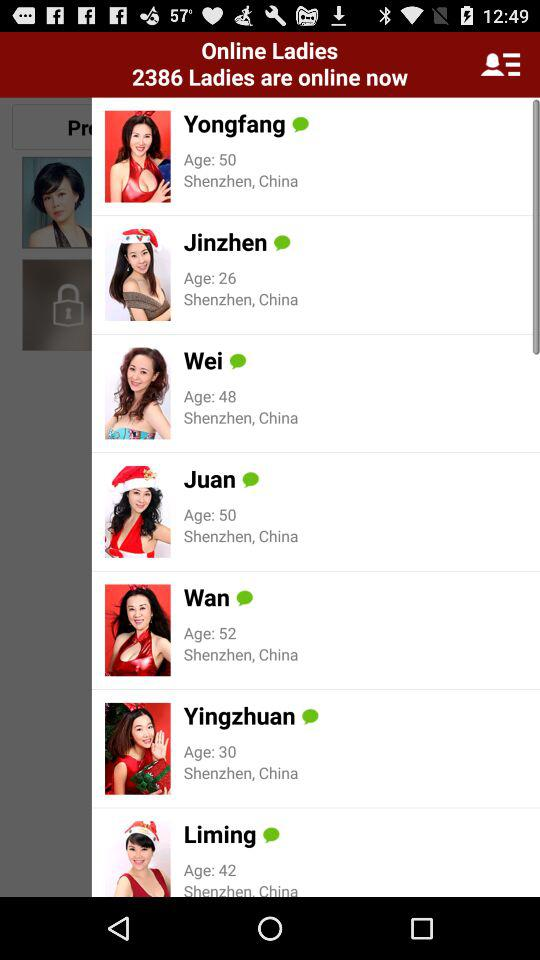How far away is Juan?
When the provided information is insufficient, respond with <no answer>. <no answer> 